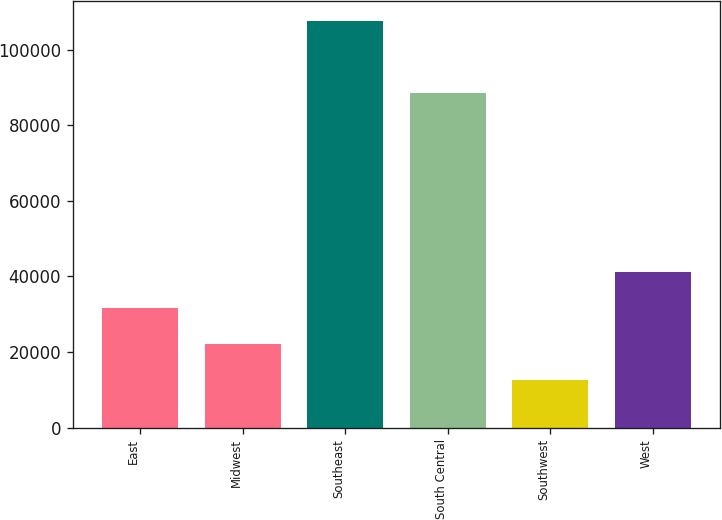<chart> <loc_0><loc_0><loc_500><loc_500><bar_chart><fcel>East<fcel>Midwest<fcel>Southeast<fcel>South Central<fcel>Southwest<fcel>West<nl><fcel>31580<fcel>22090<fcel>107500<fcel>88600<fcel>12600<fcel>41070<nl></chart> 